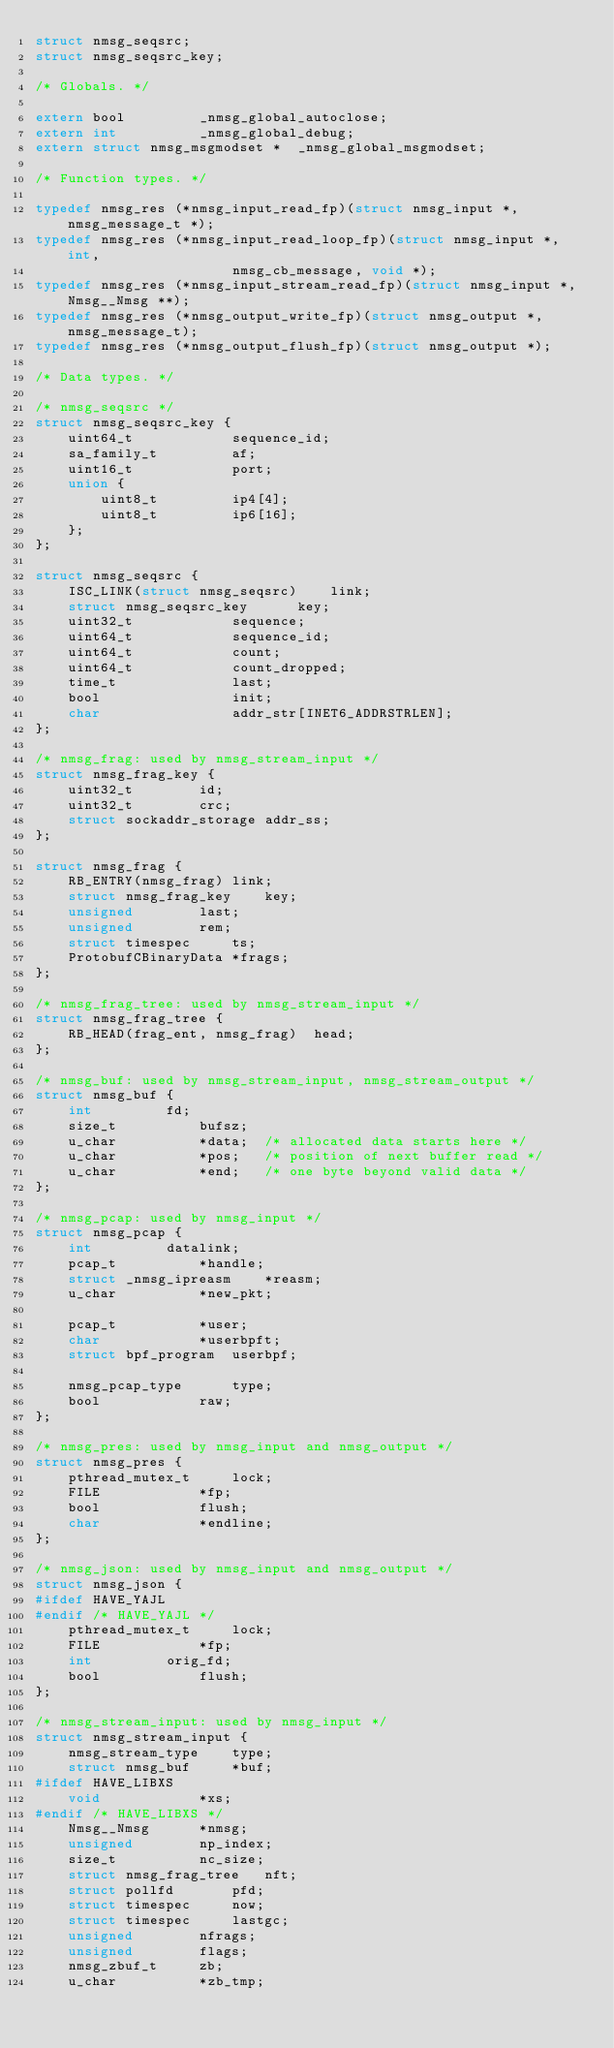<code> <loc_0><loc_0><loc_500><loc_500><_C_>struct nmsg_seqsrc;
struct nmsg_seqsrc_key;

/* Globals. */

extern bool			_nmsg_global_autoclose;
extern int			_nmsg_global_debug;
extern struct nmsg_msgmodset *	_nmsg_global_msgmodset;

/* Function types. */

typedef nmsg_res (*nmsg_input_read_fp)(struct nmsg_input *, nmsg_message_t *);
typedef nmsg_res (*nmsg_input_read_loop_fp)(struct nmsg_input *, int,
					    nmsg_cb_message, void *);
typedef nmsg_res (*nmsg_input_stream_read_fp)(struct nmsg_input *, Nmsg__Nmsg **);
typedef nmsg_res (*nmsg_output_write_fp)(struct nmsg_output *, nmsg_message_t);
typedef nmsg_res (*nmsg_output_flush_fp)(struct nmsg_output *);

/* Data types. */

/* nmsg_seqsrc */
struct nmsg_seqsrc_key {
	uint64_t			sequence_id;
	sa_family_t			af;
	uint16_t			port;
	union {
		uint8_t			ip4[4];
		uint8_t			ip6[16];
	};
};

struct nmsg_seqsrc {
	ISC_LINK(struct nmsg_seqsrc)	link;
	struct nmsg_seqsrc_key		key;
	uint32_t			sequence;
	uint64_t			sequence_id;
	uint64_t			count;
	uint64_t			count_dropped;
	time_t				last;
	bool				init;
	char				addr_str[INET6_ADDRSTRLEN];
};

/* nmsg_frag: used by nmsg_stream_input */
struct nmsg_frag_key {
	uint32_t		id;
	uint32_t		crc;
	struct sockaddr_storage	addr_ss;
};

struct nmsg_frag {
	RB_ENTRY(nmsg_frag)	link;
	struct nmsg_frag_key	key;
	unsigned		last;
	unsigned		rem;
	struct timespec		ts;
	ProtobufCBinaryData	*frags;
};

/* nmsg_frag_tree: used by nmsg_stream_input */
struct nmsg_frag_tree {
	RB_HEAD(frag_ent, nmsg_frag)  head;
};

/* nmsg_buf: used by nmsg_stream_input, nmsg_stream_output */
struct nmsg_buf {
	int			fd;
	size_t			bufsz;
	u_char			*data;	/* allocated data starts here */
	u_char			*pos;	/* position of next buffer read */
	u_char			*end;	/* one byte beyond valid data */
};

/* nmsg_pcap: used by nmsg_input */
struct nmsg_pcap {
	int			datalink;
	pcap_t			*handle;
	struct _nmsg_ipreasm	*reasm;
	u_char			*new_pkt;

	pcap_t			*user;
	char			*userbpft;
	struct bpf_program	userbpf;

	nmsg_pcap_type		type;
	bool			raw;
};

/* nmsg_pres: used by nmsg_input and nmsg_output */
struct nmsg_pres {
	pthread_mutex_t		lock;
	FILE			*fp;
	bool			flush;
	char			*endline;
};

/* nmsg_json: used by nmsg_input and nmsg_output */
struct nmsg_json {
#ifdef HAVE_YAJL
#endif /* HAVE_YAJL */
	pthread_mutex_t		lock;
	FILE			*fp;
	int			orig_fd;
	bool			flush;
};

/* nmsg_stream_input: used by nmsg_input */
struct nmsg_stream_input {
	nmsg_stream_type	type;
	struct nmsg_buf		*buf;
#ifdef HAVE_LIBXS
	void			*xs;
#endif /* HAVE_LIBXS */
	Nmsg__Nmsg		*nmsg;
	unsigned		np_index;
	size_t			nc_size;
	struct nmsg_frag_tree	nft;
	struct pollfd		pfd;
	struct timespec		now;
	struct timespec		lastgc;
	unsigned		nfrags;
	unsigned		flags;
	nmsg_zbuf_t		zb;
	u_char			*zb_tmp;</code> 